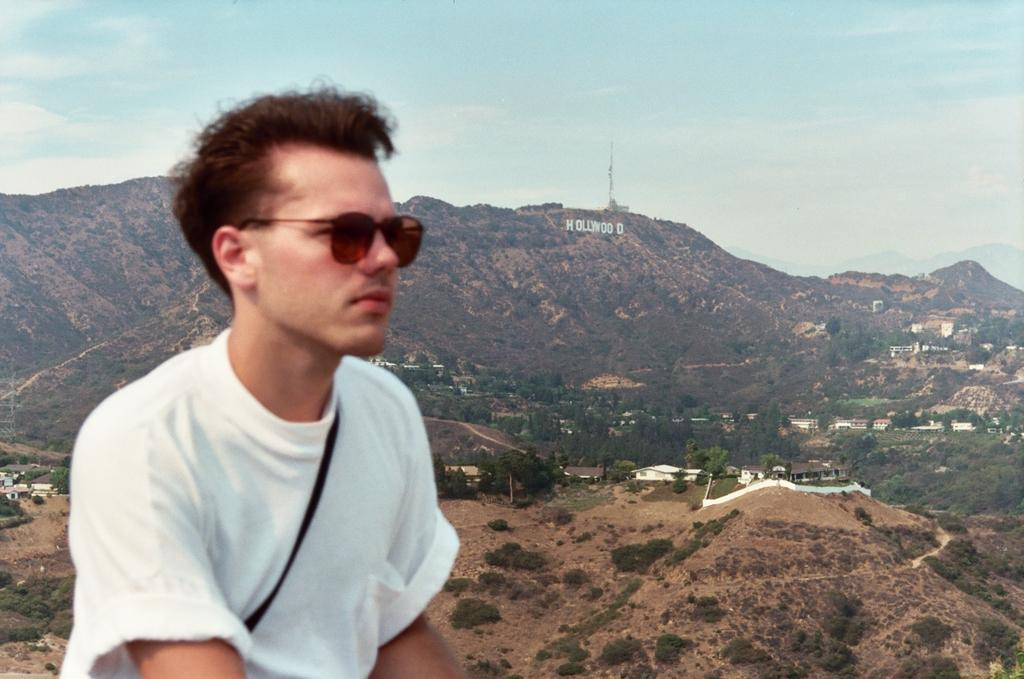What is the main subject of the image? There is a person in the image. What is the person wearing that is visible in the image? The person is wearing goggles. What can be seen in the background of the image? There are trees, houses, poles, plants, hills, and the sky visible in the background of the image. Can you describe the text in the image? There is some text in the image, but its content is not clear from the provided facts. Reasoning: Let'g: Let's think step by step in order to produce the conversation. We start by identifying the main subject of the image, which is the person. Then, we describe the person's appearance, focusing on the goggles. Next, we expand the conversation to include the background of the image, noting the presence of various elements such as trees, houses, poles, plants, hills, and the sky. Finally, we acknowledge the presence of text in the image, but since its content is not specified, we cannot provide more details. Absurd Question/Answer: What type of cloth is being used to commit a crime in the image? There is no mention of a crime or cloth in the image; it features a person wearing goggles with various background elements. 